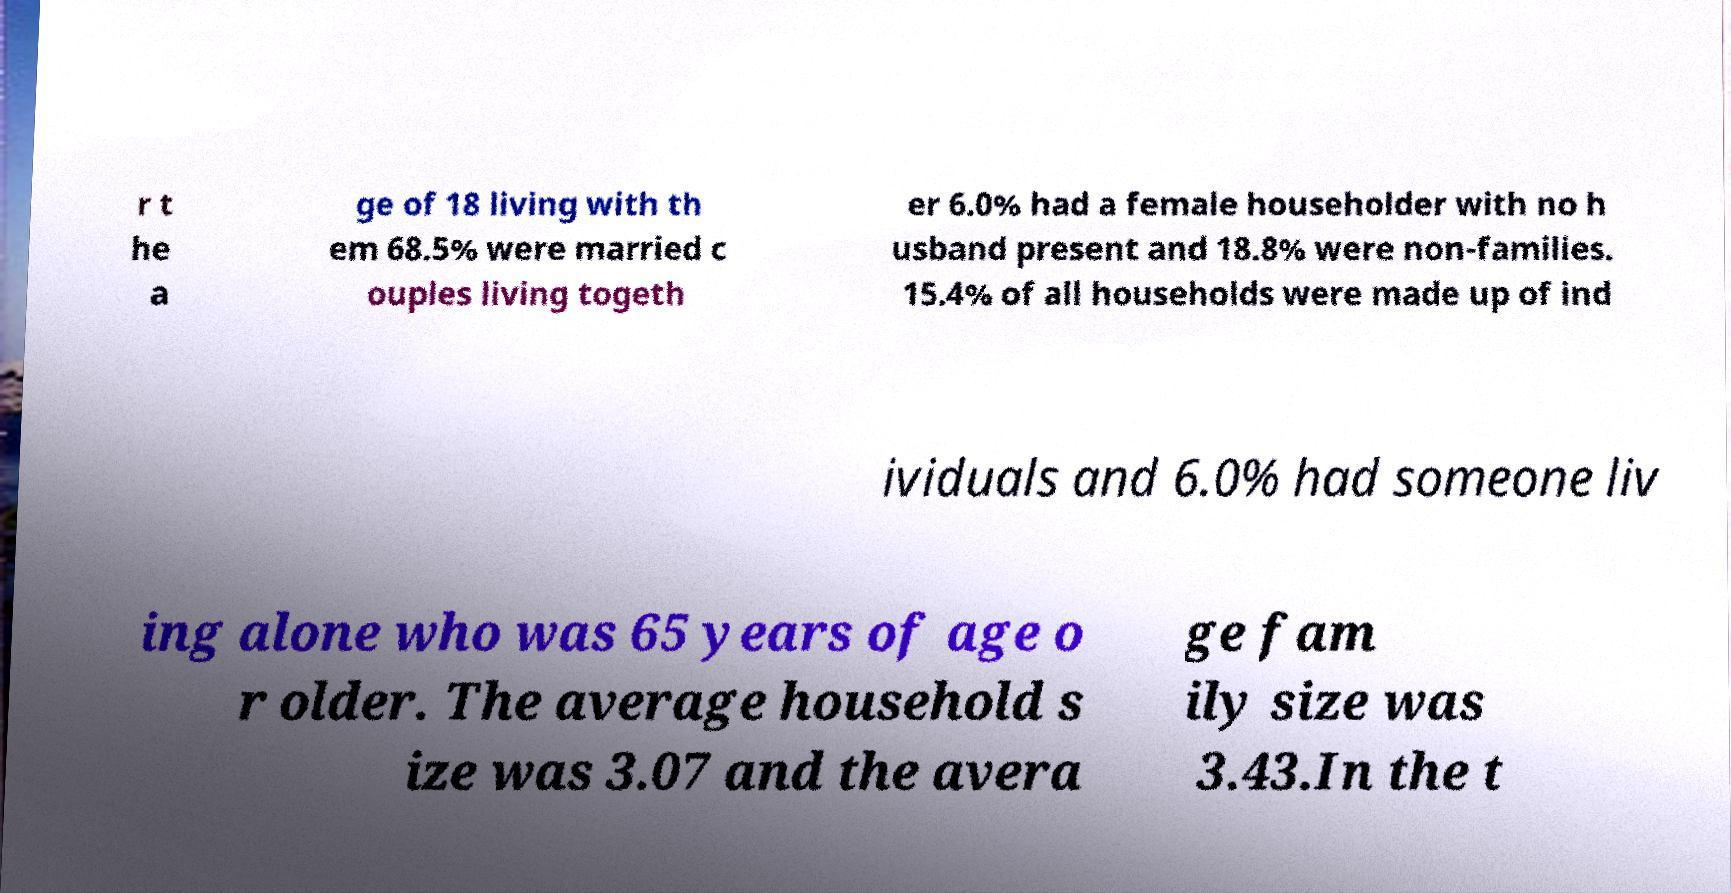I need the written content from this picture converted into text. Can you do that? r t he a ge of 18 living with th em 68.5% were married c ouples living togeth er 6.0% had a female householder with no h usband present and 18.8% were non-families. 15.4% of all households were made up of ind ividuals and 6.0% had someone liv ing alone who was 65 years of age o r older. The average household s ize was 3.07 and the avera ge fam ily size was 3.43.In the t 